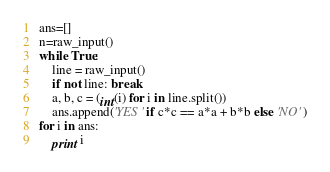<code> <loc_0><loc_0><loc_500><loc_500><_Python_>ans=[]
n=raw_input()
while True:
    line = raw_input()
    if not line: break
    a, b, c = (int(i) for i in line.split())
    ans.append('YES' if c*c == a*a + b*b else 'NO' )
for i in ans:
    print i</code> 